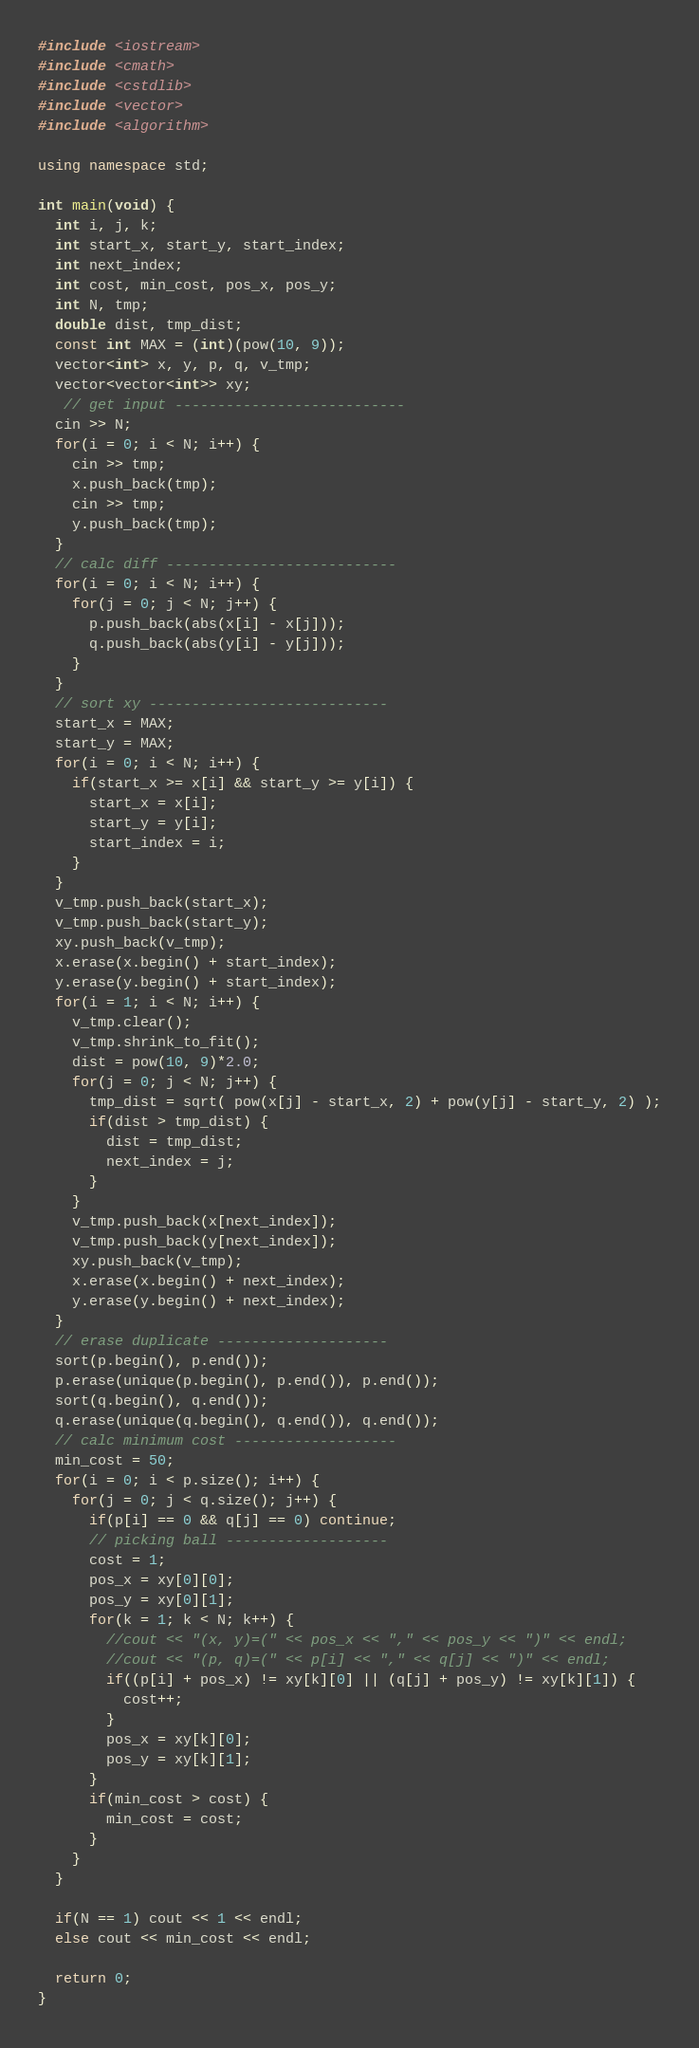<code> <loc_0><loc_0><loc_500><loc_500><_C++_>#include <iostream>
#include <cmath>
#include <cstdlib>
#include <vector>
#include <algorithm>

using namespace std;

int main(void) {
  int i, j, k;
  int start_x, start_y, start_index;
  int next_index;
  int cost, min_cost, pos_x, pos_y;
  int N, tmp;
  double dist, tmp_dist;
  const int MAX = (int)(pow(10, 9));
  vector<int> x, y, p, q, v_tmp;
  vector<vector<int>> xy;
   // get input ---------------------------
  cin >> N;
  for(i = 0; i < N; i++) {
    cin >> tmp;
    x.push_back(tmp);
    cin >> tmp;
    y.push_back(tmp);
  }
  // calc diff ---------------------------
  for(i = 0; i < N; i++) {
    for(j = 0; j < N; j++) {
      p.push_back(abs(x[i] - x[j]));
      q.push_back(abs(y[i] - y[j]));
    }
  }
  // sort xy ----------------------------
  start_x = MAX;
  start_y = MAX;
  for(i = 0; i < N; i++) {
    if(start_x >= x[i] && start_y >= y[i]) {
      start_x = x[i];
      start_y = y[i];
      start_index = i;
    }
  }
  v_tmp.push_back(start_x);
  v_tmp.push_back(start_y);
  xy.push_back(v_tmp);
  x.erase(x.begin() + start_index);
  y.erase(y.begin() + start_index);
  for(i = 1; i < N; i++) {
    v_tmp.clear();
    v_tmp.shrink_to_fit();
    dist = pow(10, 9)*2.0;
    for(j = 0; j < N; j++) {
      tmp_dist = sqrt( pow(x[j] - start_x, 2) + pow(y[j] - start_y, 2) );
      if(dist > tmp_dist) {
        dist = tmp_dist;
        next_index = j;
      }
    }
    v_tmp.push_back(x[next_index]);
  	v_tmp.push_back(y[next_index]);
  	xy.push_back(v_tmp);
  	x.erase(x.begin() + next_index);
  	y.erase(y.begin() + next_index);
  }
  // erase duplicate --------------------
  sort(p.begin(), p.end());
  p.erase(unique(p.begin(), p.end()), p.end());
  sort(q.begin(), q.end());
  q.erase(unique(q.begin(), q.end()), q.end());
  // calc minimum cost -------------------
  min_cost = 50;
  for(i = 0; i < p.size(); i++) {
    for(j = 0; j < q.size(); j++) {
      if(p[i] == 0 && q[j] == 0) continue;
      // picking ball -------------------
      cost = 1;
      pos_x = xy[0][0];
      pos_y = xy[0][1];
      for(k = 1; k < N; k++) {
        //cout << "(x, y)=(" << pos_x << "," << pos_y << ")" << endl;
        //cout << "(p, q)=(" << p[i] << "," << q[j] << ")" << endl;
        if((p[i] + pos_x) != xy[k][0] || (q[j] + pos_y) != xy[k][1]) {
          cost++;
        }
        pos_x = xy[k][0];
        pos_y = xy[k][1];
      }
      if(min_cost > cost) {
        min_cost = cost;
      }
    }
  }
  
  if(N == 1) cout << 1 << endl;
  else cout << min_cost << endl;
  
  return 0;
}</code> 